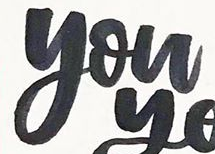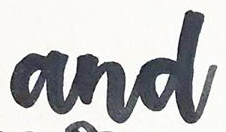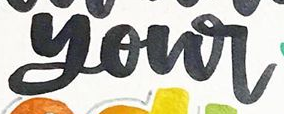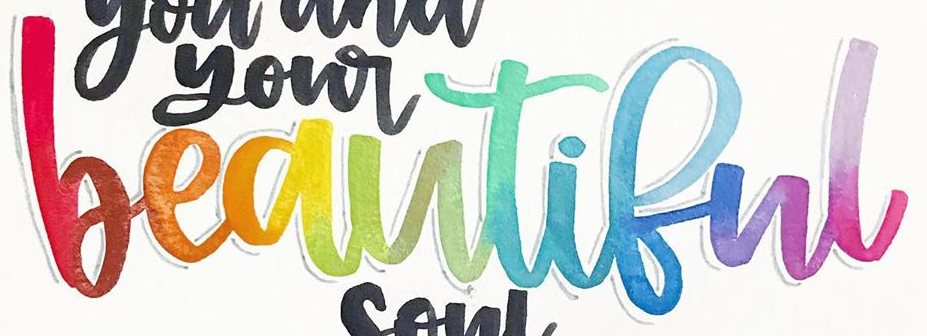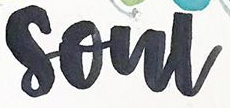Read the text content from these images in order, separated by a semicolon. you; and; your; beautiful; soul 